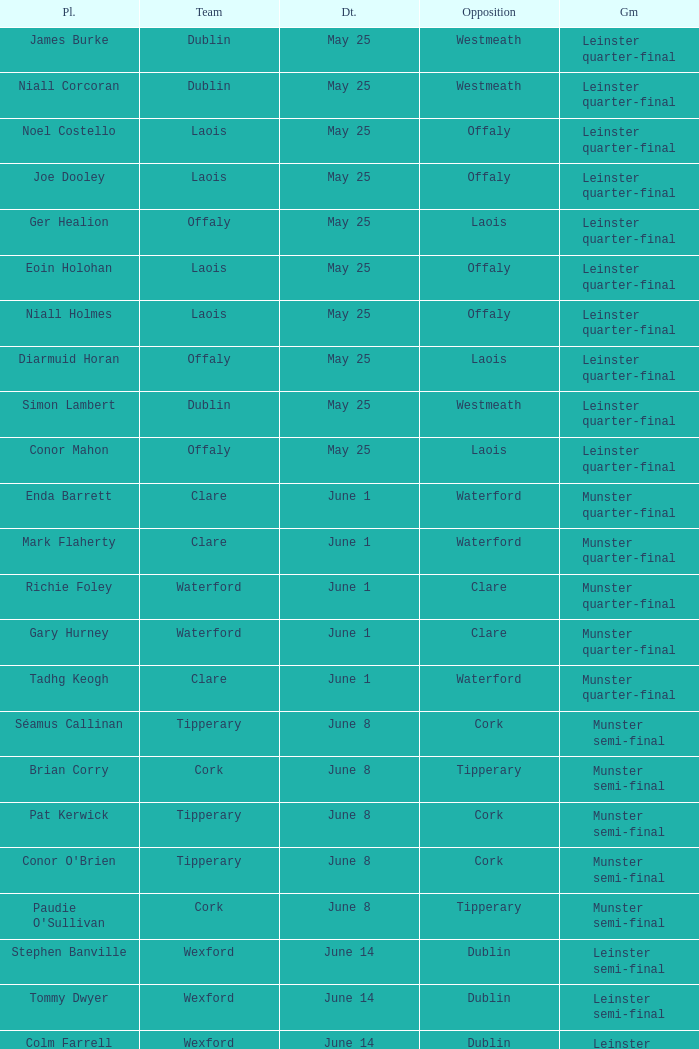What game did Eoin Holohan play in? Leinster quarter-final. 